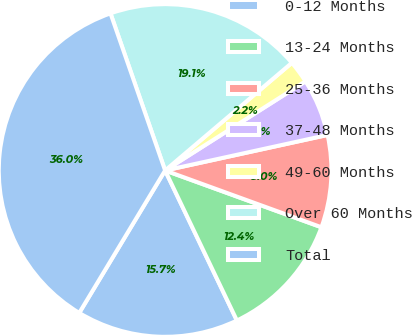Convert chart to OTSL. <chart><loc_0><loc_0><loc_500><loc_500><pie_chart><fcel>0-12 Months<fcel>13-24 Months<fcel>25-36 Months<fcel>37-48 Months<fcel>49-60 Months<fcel>Over 60 Months<fcel>Total<nl><fcel>15.74%<fcel>12.35%<fcel>8.97%<fcel>5.58%<fcel>2.2%<fcel>19.12%<fcel>36.04%<nl></chart> 